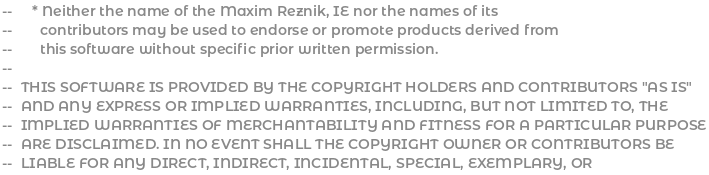Convert code to text. <code><loc_0><loc_0><loc_500><loc_500><_Ada_>--     * Neither the name of the Maxim Reznik, IE nor the names of its
--       contributors may be used to endorse or promote products derived from
--       this software without specific prior written permission.
--
--  THIS SOFTWARE IS PROVIDED BY THE COPYRIGHT HOLDERS AND CONTRIBUTORS "AS IS"
--  AND ANY EXPRESS OR IMPLIED WARRANTIES, INCLUDING, BUT NOT LIMITED TO, THE
--  IMPLIED WARRANTIES OF MERCHANTABILITY AND FITNESS FOR A PARTICULAR PURPOSE
--  ARE DISCLAIMED. IN NO EVENT SHALL THE COPYRIGHT OWNER OR CONTRIBUTORS BE
--  LIABLE FOR ANY DIRECT, INDIRECT, INCIDENTAL, SPECIAL, EXEMPLARY, OR</code> 